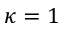<formula> <loc_0><loc_0><loc_500><loc_500>\kappa = 1</formula> 